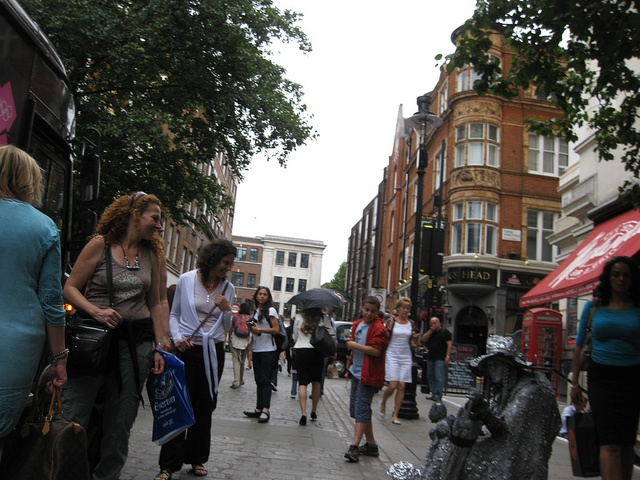Describe the objects in this image and their specific colors. I can see people in black, maroon, and gray tones, people in black, blue, darkblue, and gray tones, people in black, darkblue, blue, and maroon tones, people in black and gray tones, and handbag in black, maroon, and gray tones in this image. 